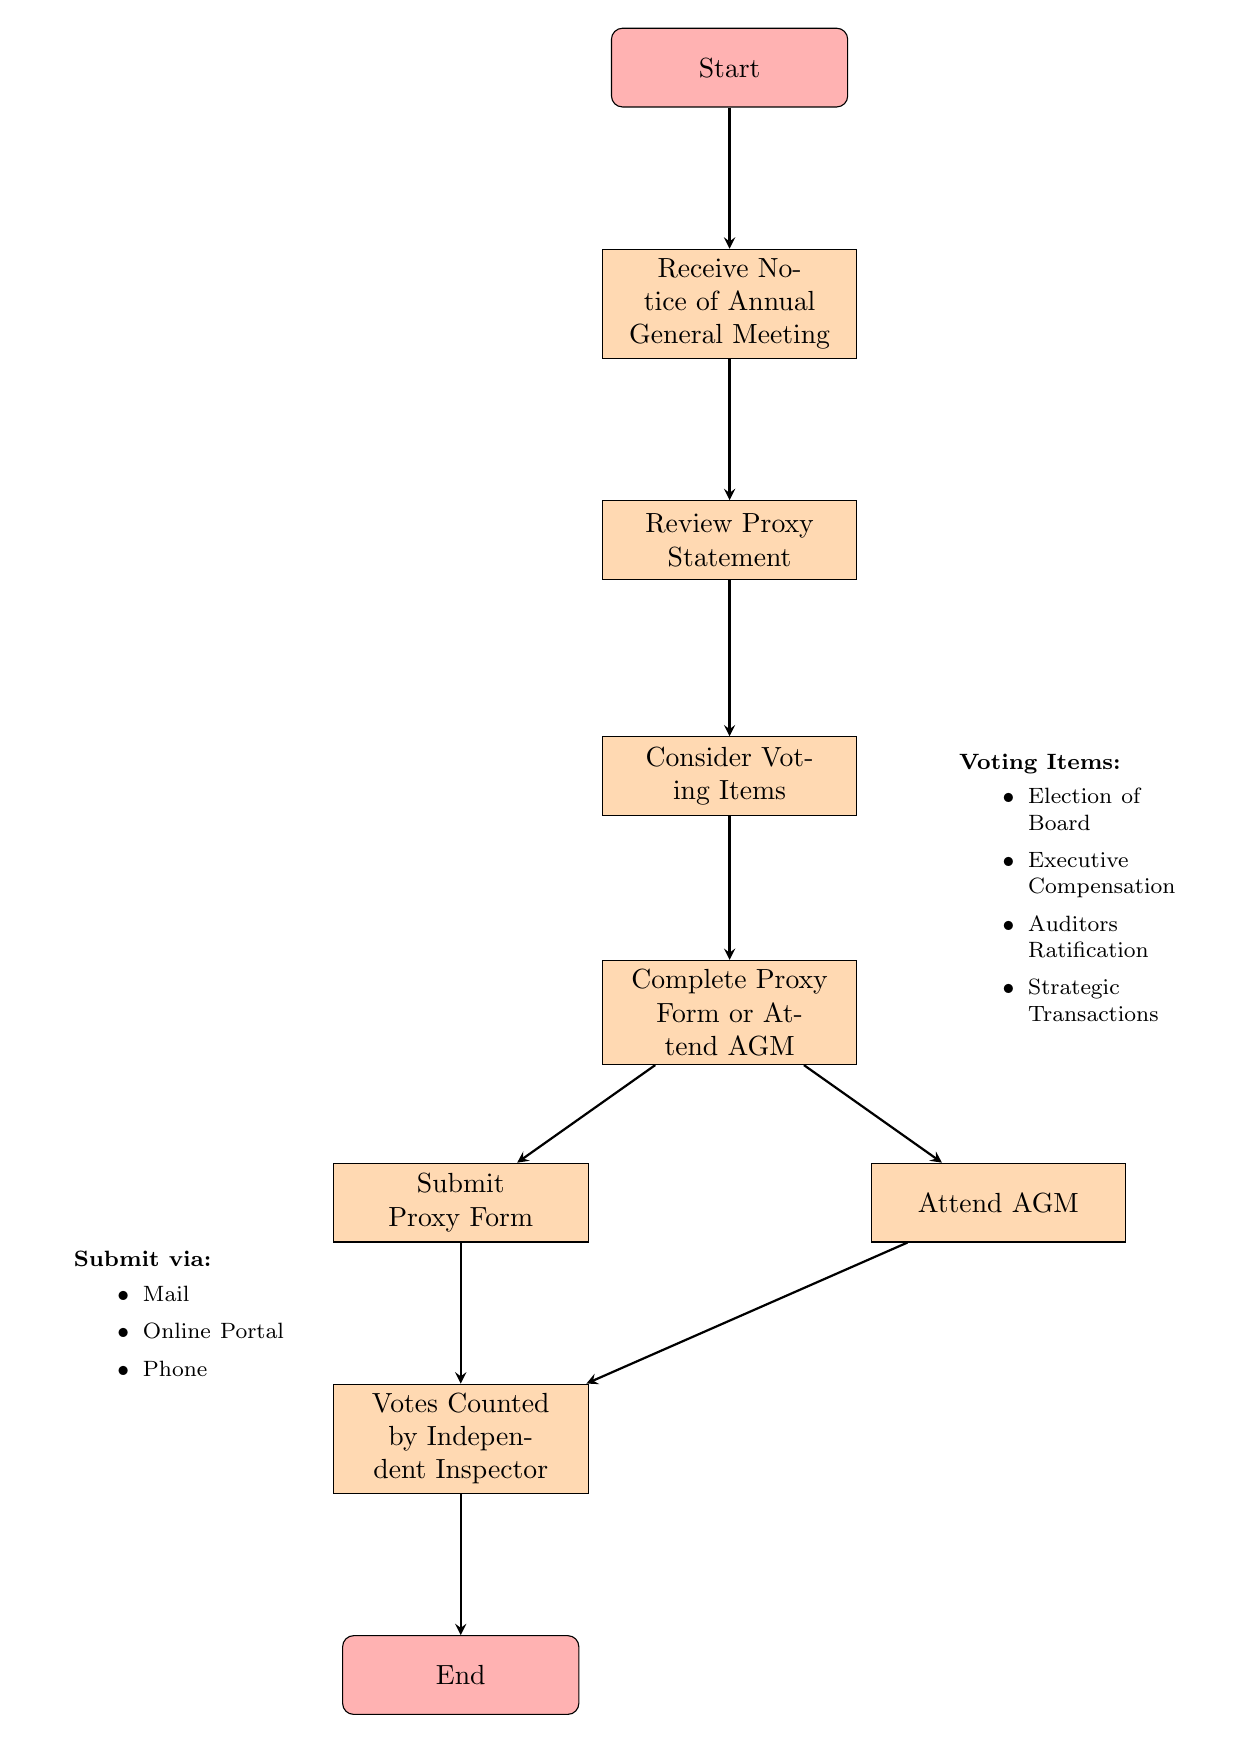What is the first step in the voting procedure? The first step listed in the diagram is "Receive Notice of Annual General Meeting". This is the starting point of the flow chart, and no other action occurs before this step.
Answer: Receive Notice of Annual General Meeting How many voting items are considered? The diagram specifies four voting items listed under "Consider Voting Items". Therefore, when counted, the total is four.
Answer: Four What are the methods available to submit the proxy form? The flow chart indicates three methods to submit the proxy form: Mail, Online Portal, and Phone. This is detailed in the node that lists submission methods.
Answer: Mail, Online Portal, Phone Which action follows "Complete Proxy Form or Attend AGM"? After the action of completing a proxy form or attending the annual general meeting (AGM), the next step outlined in the chart is to either "Submit Proxy Form" or "Attend AGM". The flow splits here into two possible paths.
Answer: Submit Proxy Form or Attend AGM Where do votes get counted? The votes are counted by an "Independent Inspector", as mentioned in the flow chart after the submission or attendance steps. This highlights the critical trust mechanism in the voting process.
Answer: Votes Counted by Independent Inspector What happens after the votes are counted? After the votes are counted by the Independent Inspector, the final step in the flow process is "End", which signifies the conclusion of the voting procedure.
Answer: End How many nodes are there in total in the diagram? The diagram presents a total of eight nodes, counting from the start to the end, including all major steps and actions in the process.
Answer: Eight What is the last action taken in the flow chart? The last action taken, as per the diagram, is "End". This signifies that after the votes are counted, the voting procedure is complete.
Answer: End 